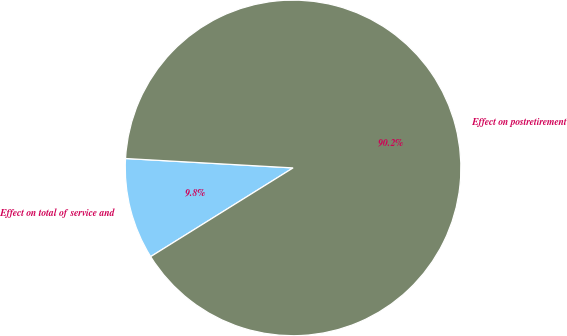Convert chart. <chart><loc_0><loc_0><loc_500><loc_500><pie_chart><fcel>Effect on total of service and<fcel>Effect on postretirement<nl><fcel>9.76%<fcel>90.24%<nl></chart> 